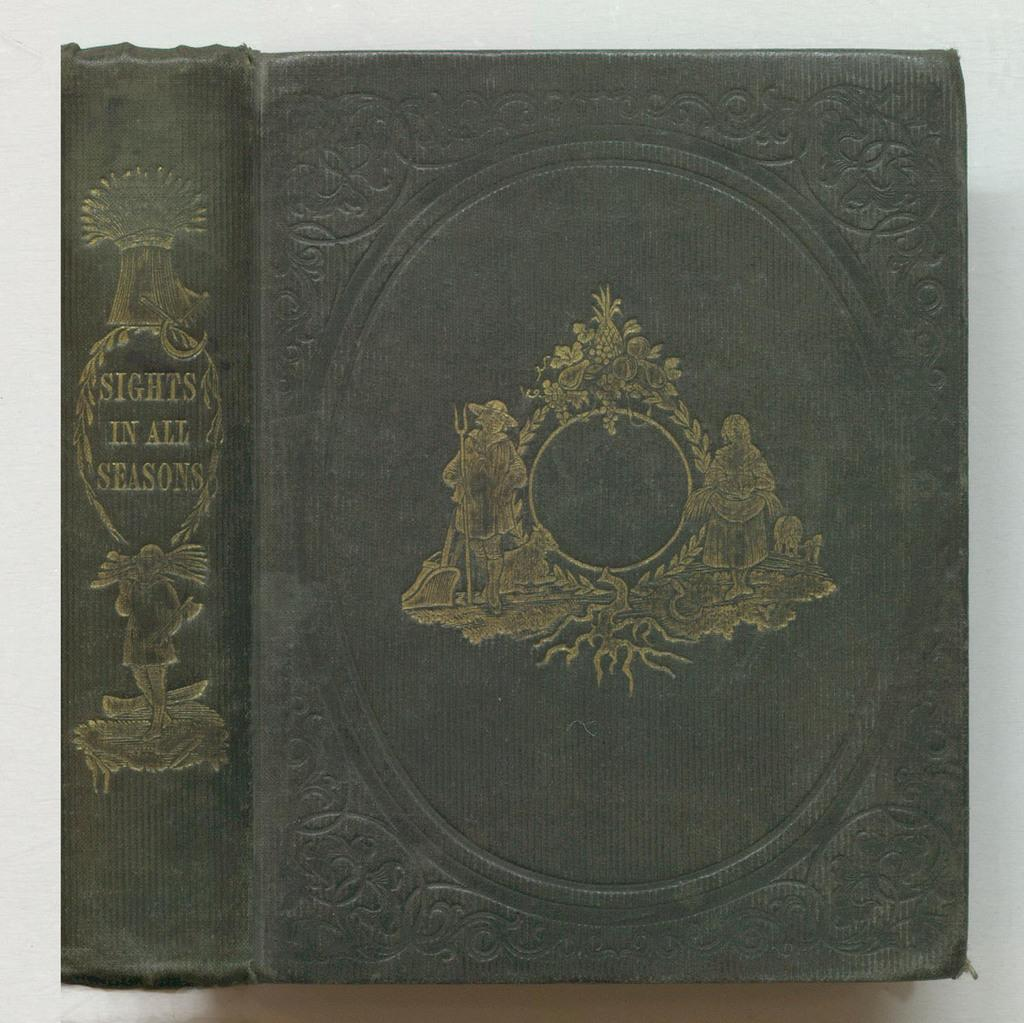<image>
Describe the image concisely. A dark grey antique book is called Sights in All Seasons with a gold emblem on front 